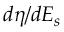Convert formula to latex. <formula><loc_0><loc_0><loc_500><loc_500>d \eta / d E _ { s }</formula> 